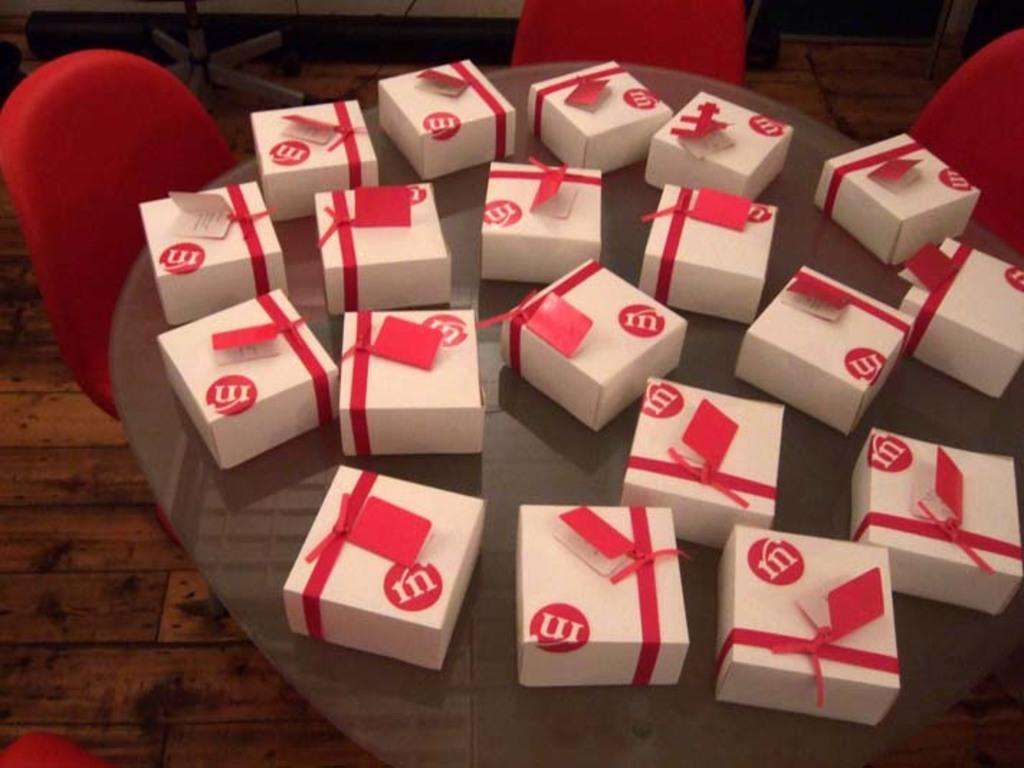<image>
Summarize the visual content of the image. A collection of small gift boxes have the letters rn on them. 